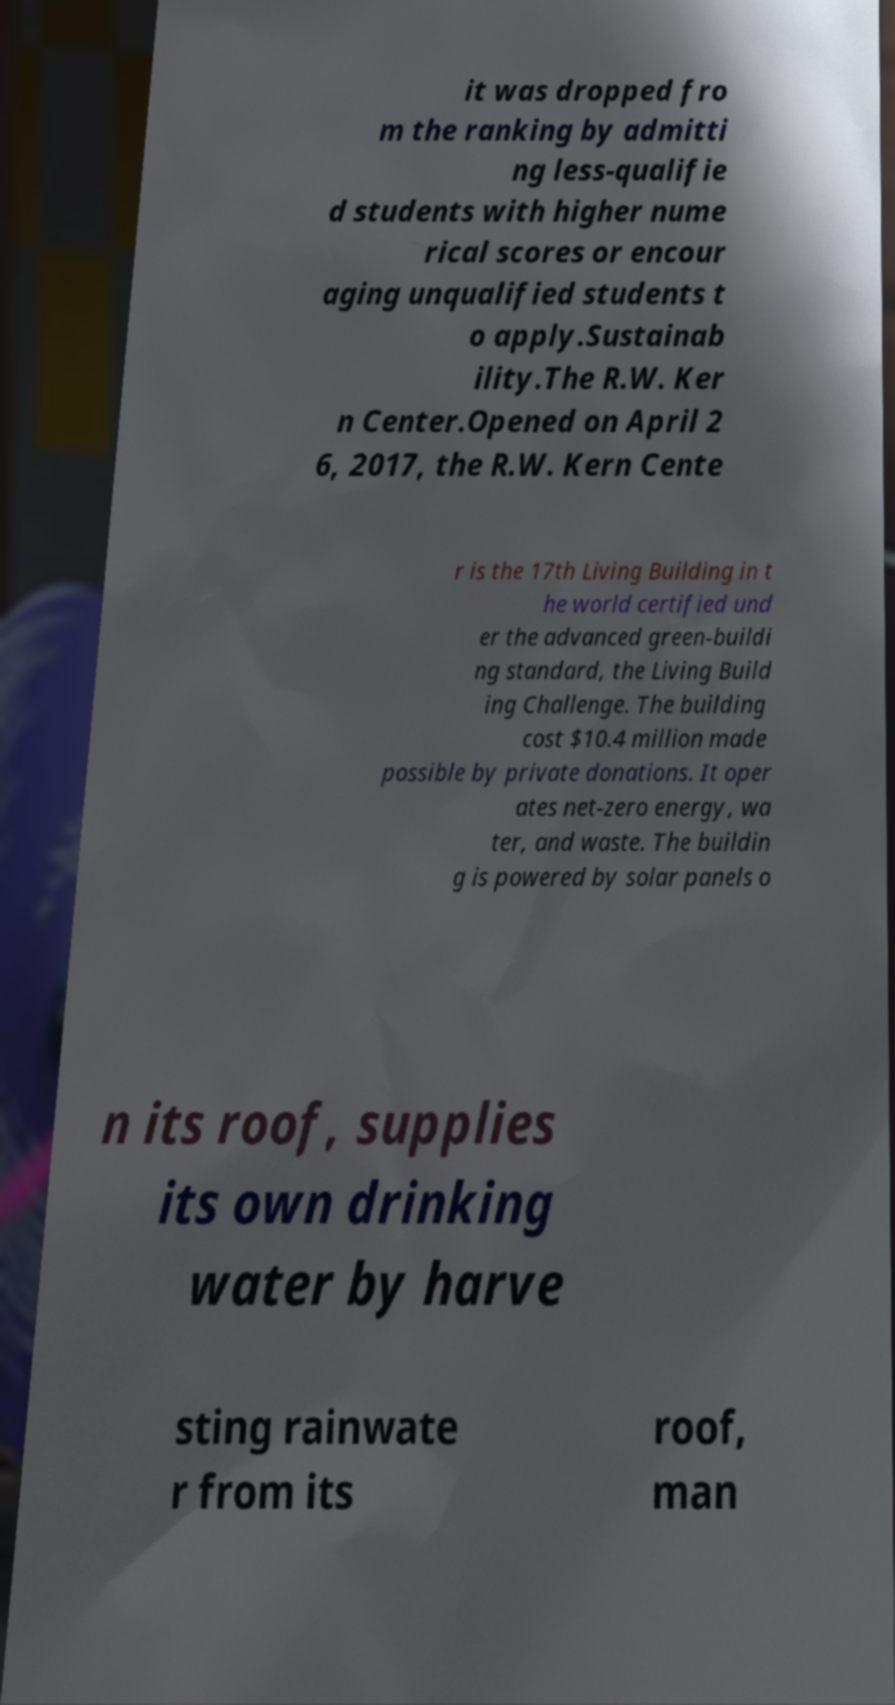Can you accurately transcribe the text from the provided image for me? it was dropped fro m the ranking by admitti ng less-qualifie d students with higher nume rical scores or encour aging unqualified students t o apply.Sustainab ility.The R.W. Ker n Center.Opened on April 2 6, 2017, the R.W. Kern Cente r is the 17th Living Building in t he world certified und er the advanced green-buildi ng standard, the Living Build ing Challenge. The building cost $10.4 million made possible by private donations. It oper ates net-zero energy, wa ter, and waste. The buildin g is powered by solar panels o n its roof, supplies its own drinking water by harve sting rainwate r from its roof, man 